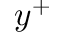Convert formula to latex. <formula><loc_0><loc_0><loc_500><loc_500>y ^ { + }</formula> 